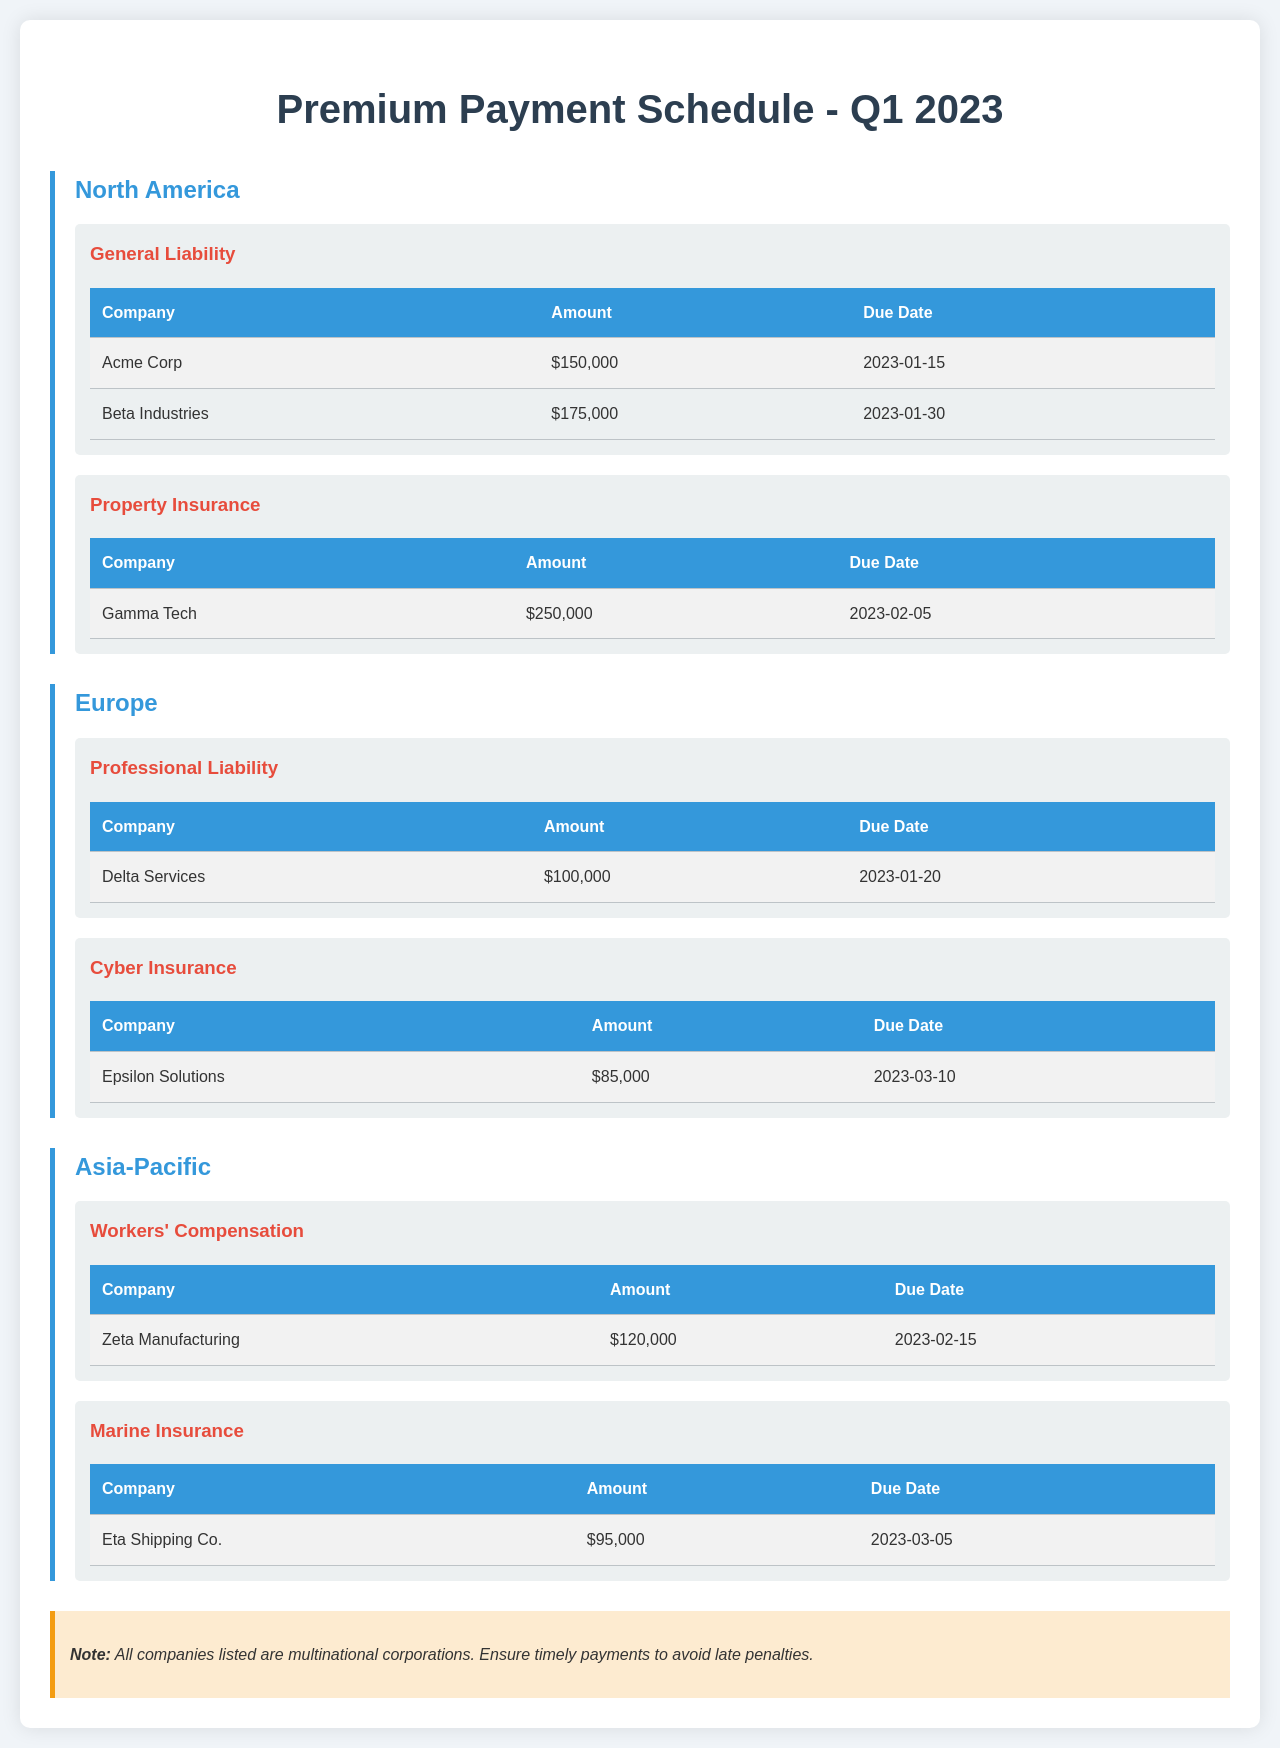What is the due date for Acme Corp's payment? Acme Corp's payment due date is listed in the General Liability section of North America.
Answer: 2023-01-15 How much is the payment for Delta Services? The payment amount for Delta Services is specified in the Professional Liability section of Europe.
Answer: $100,000 What type of insurance does Zeta Manufacturing have? Zeta Manufacturing has Workers' Compensation as their coverage type in the Asia-Pacific region.
Answer: Workers' Compensation Which company has a payment due on March 10, 2023? The document indicates that Epsilon Solutions has a payment due on that date in the Cyber Insurance section of Europe.
Answer: Epsilon Solutions What is the total amount due for General Liability in North America? The total for General Liability includes Acme Corp and Beta Industries' payments. $150,000 + $175,000 = $325,000.
Answer: $325,000 How many coverage types are listed for the Asia-Pacific region? The Asia-Pacific region has two coverage types listed in the document.
Answer: 2 What is the total amount due for Property Insurance? The document shows the amount due for only one company, Gamma Tech, under Property Insurance in North America.
Answer: $250,000 Which region has the highest minimum due date among listed companies? Comparing the due dates, North America has the earliest payments, while Europe has the latest payment due on March 10.
Answer: Europe Which company pays the least in Q1 2023? The document indicates that Epsilon Solutions has the lowest payment amount due among the listed companies.
Answer: $85,000 